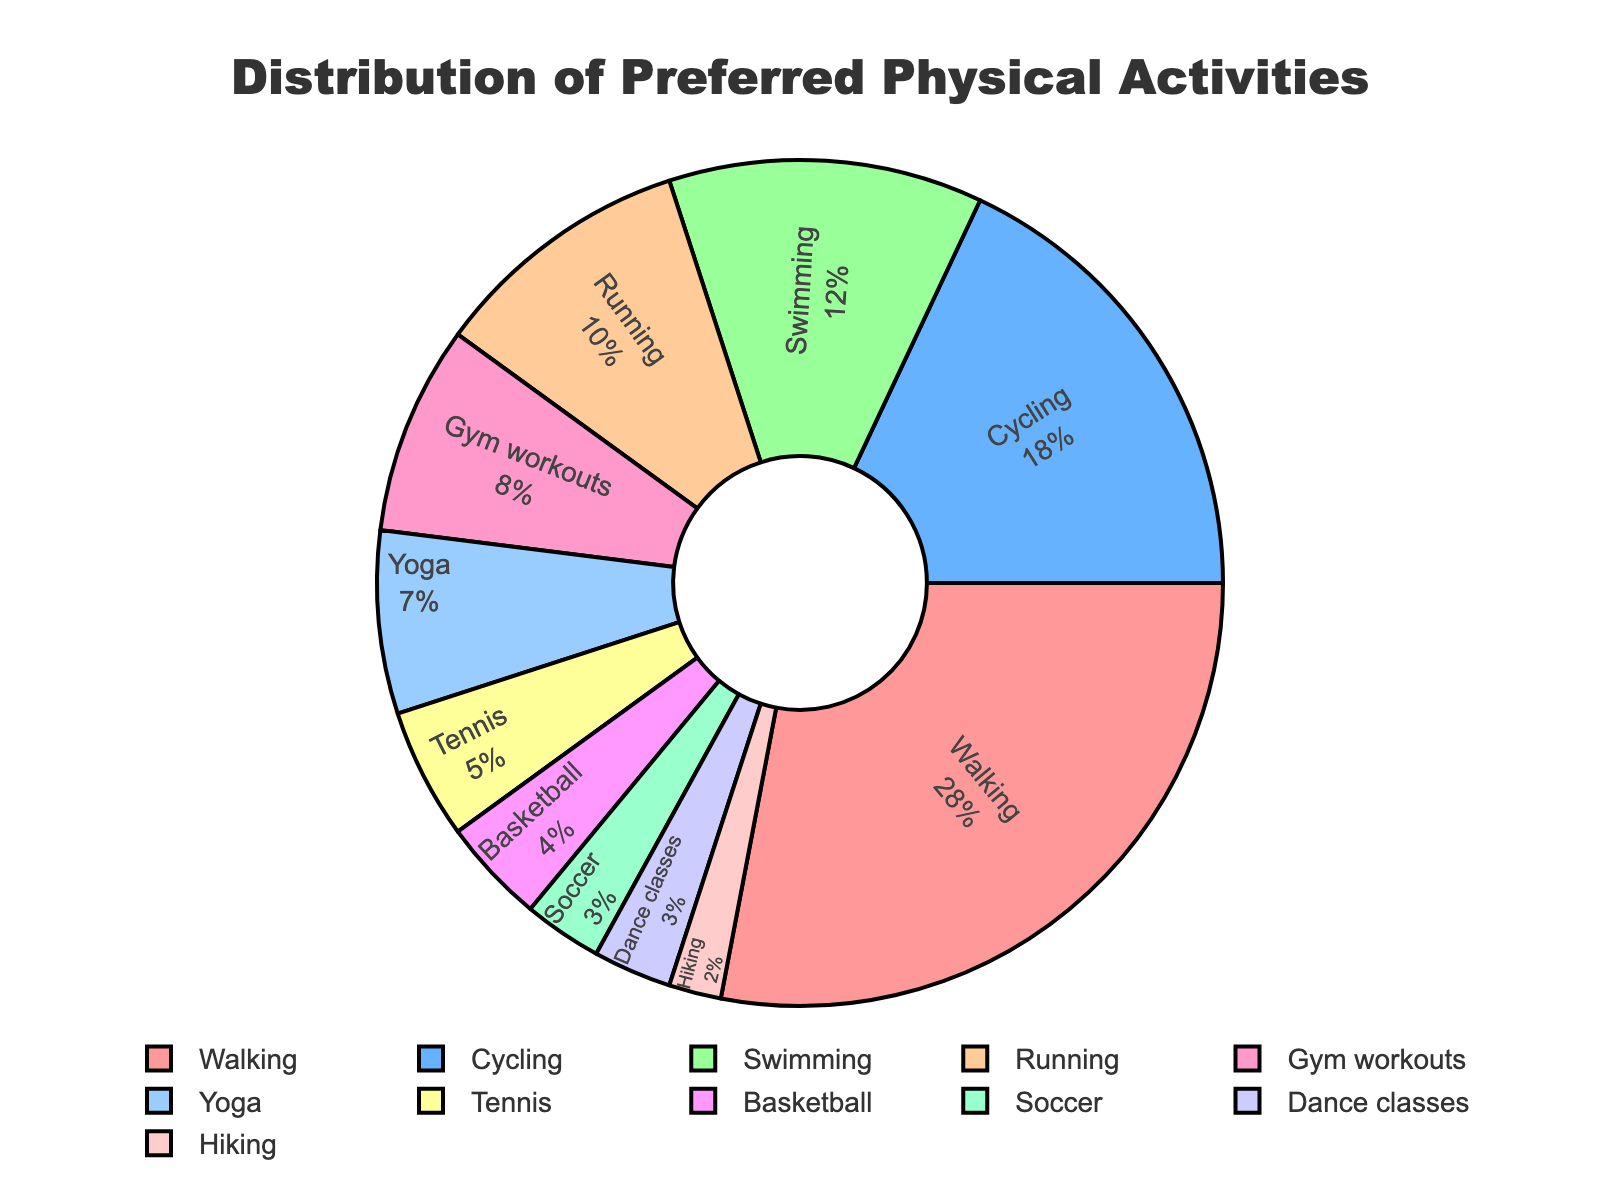What percentage of local residents prefer walking? To find the percentage of residents who prefer walking, look at the section labeled "Walking" in the chart. It shows that walking has a segment that represents 28%.
Answer: 28% Which activity is more popular, Cycling or Gym workouts? To determine the more popular activity between Cycling and Gym workouts, compare their percentages from the chart. Cycling has 18%, while Gym workouts have 8%. Hence, Cycling is more popular.
Answer: Cycling What is the combined percentage of residents who prefer Swimming and Running? To find the combined percentage of residents who prefer Swimming and Running, add their individual percentages. Swimming is 12% and Running is 10%, so the combined percentage is 12% + 10% = 22%.
Answer: 22% How much more popular is Walking compared to Tennis? To determine how much more popular Walking is compared to Tennis, subtract the percentage of residents who prefer Tennis from those who prefer Walking. Walking is 28% and Tennis is 5%, so the difference is 28% - 5% = 23%.
Answer: 23% Which activity is the least preferred, and what is its percentage? Look for the activity with the smallest segment in the pie chart. Hiking has the smallest segment with a percentage of 2%.
Answer: Hiking, 2% Is Yoga more popular than Soccer? By how much? To determine if Yoga is more popular than Soccer, compare their percentages. Yoga is 7% and Soccer is 3%, so Yoga is more popular. The difference is 7% - 3% = 4%.
Answer: Yes, by 4% How many activities have a preference percentage of 10% or greater? Review the chart and count the segments with percentages 10% or higher. Walking (28%), Cycling (18%), Swimming (12%), and Running (10%) meet this criterion. There are 4 such activities.
Answer: 4 What is the average preference percentage of the activities other than Basketball and Dance classes? First, sum the percentages of all activities except Basketball (4%) and Dance classes (3%). The total for the remaining activities is 28 + 18 + 12 + 10 + 8 + 7 + 5 + 2 = 90%. The number of these activities is 9. The average percentage is 90 / 9 = 10%.
Answer: 10% Compare the popularity of Gym workouts and Hiking. Which has a higher percentage and by how much? Compare the percentages of Gym workouts and Hiking. Gym workouts have 8%, and Hiking has 2%. Gym workouts are more popular by 8% - 2% = 6%.
Answer: Gym workouts, by 6% 